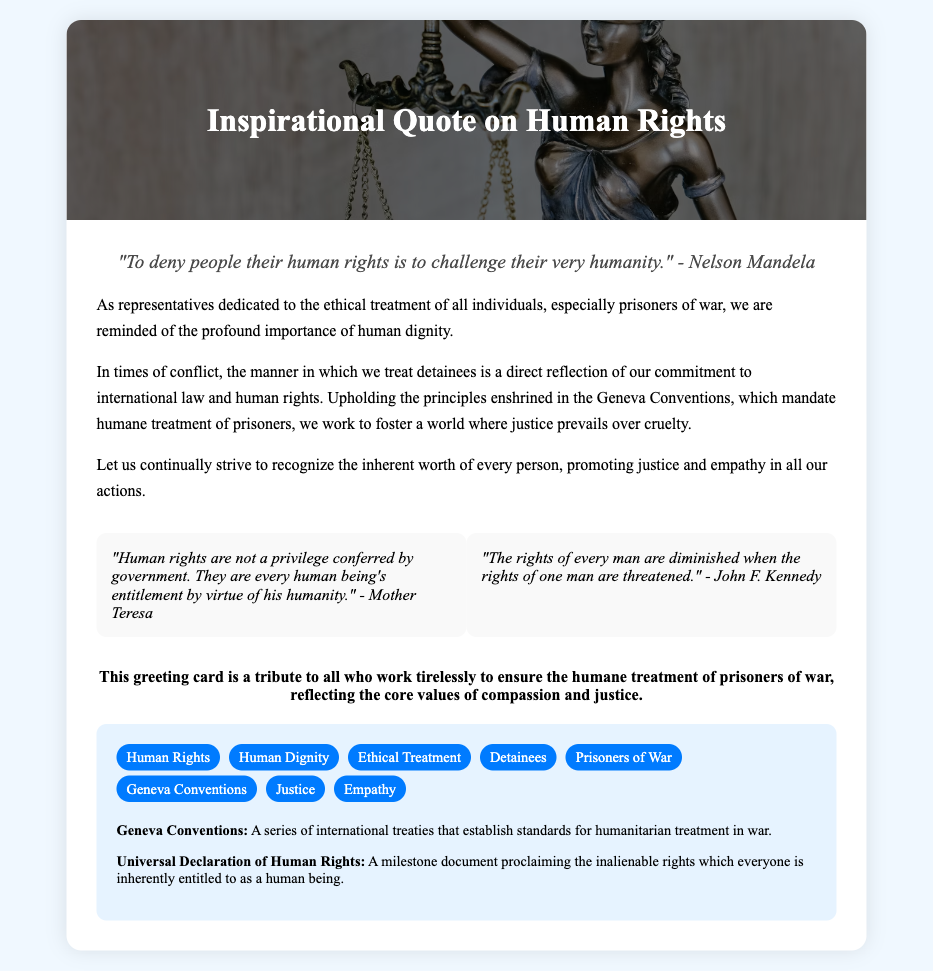what is the title of the card? The title is the heading displayed prominently at the top of the card, indicating the theme of the content.
Answer: Inspirational Quote on Human Rights who is quoted in the top quote? The top quote attributed in the card highlights a significant figure related to human rights.
Answer: Nelson Mandela what is emphasized in the message section? The message section focuses on the importance of treating individuals ethically, particularly in relation to prisoners of war.
Answer: Human dignity name one of the partner quotes. The partner quotes are additional inspirational statements included in the card to reinforce its theme.
Answer: "Human rights are not a privilege conferred by government. They are every human being's entitlement by virtue of his humanity." - Mother Teresa what core values does the organization note mention? The organization note summarizes the principles that guide the card's message and purpose.
Answer: Compassion and justice how many keywords are listed? The keywords serve to summarize the key themes and topics addressed in the card.
Answer: Eight what document is referenced regarding humanitarian treatment in war? This document is crucial for understanding the alternative standards for the ethical treatment of detainees during conflicts.
Answer: Geneva Conventions what color is the card's background? The background color of the card sets the overall tone and aesthetic of the document.
Answer: Light blue 